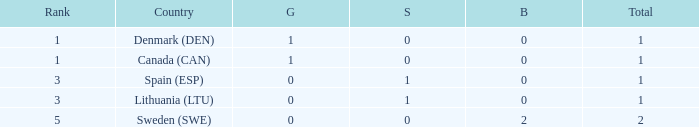What is the rank when there was less than 1 gold, 0 bronze, and more than 1 total? None. 